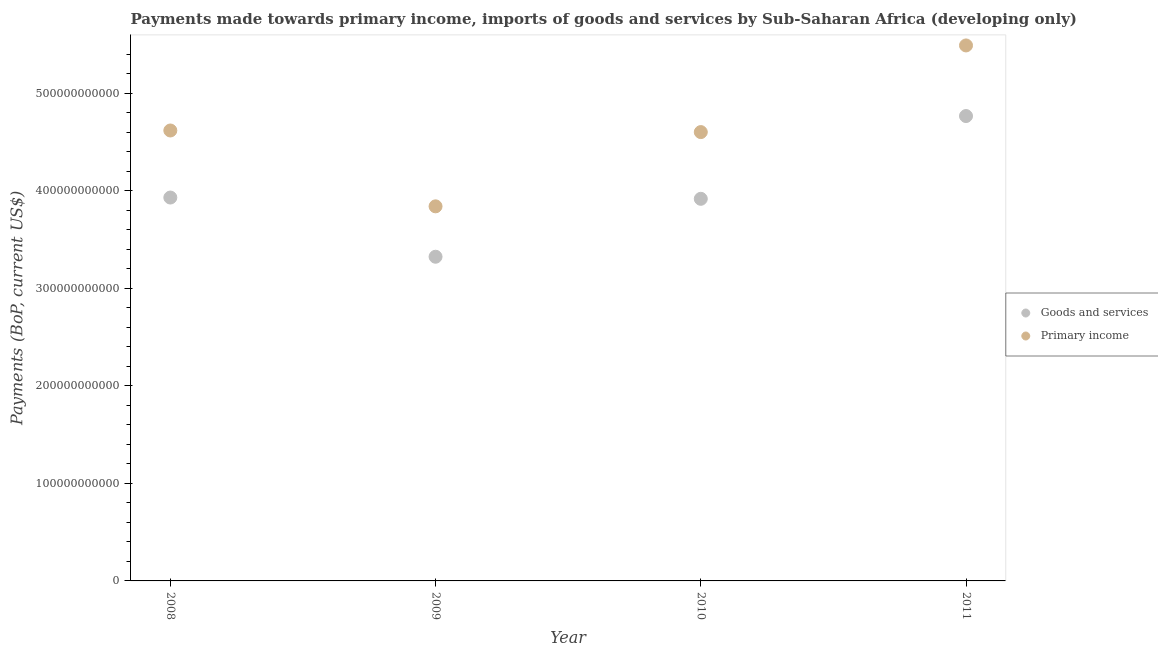Is the number of dotlines equal to the number of legend labels?
Ensure brevity in your answer.  Yes. What is the payments made towards goods and services in 2011?
Make the answer very short. 4.76e+11. Across all years, what is the maximum payments made towards goods and services?
Offer a terse response. 4.76e+11. Across all years, what is the minimum payments made towards goods and services?
Ensure brevity in your answer.  3.32e+11. In which year was the payments made towards primary income minimum?
Provide a short and direct response. 2009. What is the total payments made towards goods and services in the graph?
Offer a terse response. 1.59e+12. What is the difference between the payments made towards goods and services in 2008 and that in 2009?
Your response must be concise. 6.07e+1. What is the difference between the payments made towards goods and services in 2011 and the payments made towards primary income in 2010?
Your answer should be compact. 1.64e+1. What is the average payments made towards goods and services per year?
Keep it short and to the point. 3.98e+11. In the year 2011, what is the difference between the payments made towards goods and services and payments made towards primary income?
Your response must be concise. -7.24e+1. What is the ratio of the payments made towards goods and services in 2009 to that in 2011?
Your answer should be very brief. 0.7. Is the payments made towards primary income in 2009 less than that in 2010?
Offer a very short reply. Yes. What is the difference between the highest and the second highest payments made towards goods and services?
Keep it short and to the point. 8.35e+1. What is the difference between the highest and the lowest payments made towards goods and services?
Your answer should be compact. 1.44e+11. In how many years, is the payments made towards primary income greater than the average payments made towards primary income taken over all years?
Offer a terse response. 1. Is the sum of the payments made towards goods and services in 2009 and 2010 greater than the maximum payments made towards primary income across all years?
Offer a very short reply. Yes. How many dotlines are there?
Your answer should be compact. 2. What is the difference between two consecutive major ticks on the Y-axis?
Provide a succinct answer. 1.00e+11. Are the values on the major ticks of Y-axis written in scientific E-notation?
Your response must be concise. No. Does the graph contain any zero values?
Provide a short and direct response. No. Does the graph contain grids?
Keep it short and to the point. No. Where does the legend appear in the graph?
Your response must be concise. Center right. What is the title of the graph?
Your response must be concise. Payments made towards primary income, imports of goods and services by Sub-Saharan Africa (developing only). Does "GDP at market prices" appear as one of the legend labels in the graph?
Your answer should be very brief. No. What is the label or title of the X-axis?
Give a very brief answer. Year. What is the label or title of the Y-axis?
Keep it short and to the point. Payments (BoP, current US$). What is the Payments (BoP, current US$) in Goods and services in 2008?
Offer a terse response. 3.93e+11. What is the Payments (BoP, current US$) of Primary income in 2008?
Give a very brief answer. 4.62e+11. What is the Payments (BoP, current US$) in Goods and services in 2009?
Offer a very short reply. 3.32e+11. What is the Payments (BoP, current US$) of Primary income in 2009?
Ensure brevity in your answer.  3.84e+11. What is the Payments (BoP, current US$) of Goods and services in 2010?
Make the answer very short. 3.92e+11. What is the Payments (BoP, current US$) of Primary income in 2010?
Your answer should be very brief. 4.60e+11. What is the Payments (BoP, current US$) of Goods and services in 2011?
Make the answer very short. 4.76e+11. What is the Payments (BoP, current US$) of Primary income in 2011?
Your response must be concise. 5.49e+11. Across all years, what is the maximum Payments (BoP, current US$) of Goods and services?
Offer a terse response. 4.76e+11. Across all years, what is the maximum Payments (BoP, current US$) of Primary income?
Offer a terse response. 5.49e+11. Across all years, what is the minimum Payments (BoP, current US$) in Goods and services?
Give a very brief answer. 3.32e+11. Across all years, what is the minimum Payments (BoP, current US$) of Primary income?
Ensure brevity in your answer.  3.84e+11. What is the total Payments (BoP, current US$) of Goods and services in the graph?
Provide a short and direct response. 1.59e+12. What is the total Payments (BoP, current US$) in Primary income in the graph?
Give a very brief answer. 1.85e+12. What is the difference between the Payments (BoP, current US$) in Goods and services in 2008 and that in 2009?
Give a very brief answer. 6.07e+1. What is the difference between the Payments (BoP, current US$) of Primary income in 2008 and that in 2009?
Your response must be concise. 7.77e+1. What is the difference between the Payments (BoP, current US$) in Goods and services in 2008 and that in 2010?
Provide a short and direct response. 1.30e+09. What is the difference between the Payments (BoP, current US$) in Primary income in 2008 and that in 2010?
Keep it short and to the point. 1.64e+09. What is the difference between the Payments (BoP, current US$) in Goods and services in 2008 and that in 2011?
Offer a terse response. -8.35e+1. What is the difference between the Payments (BoP, current US$) of Primary income in 2008 and that in 2011?
Provide a short and direct response. -8.72e+1. What is the difference between the Payments (BoP, current US$) of Goods and services in 2009 and that in 2010?
Give a very brief answer. -5.94e+1. What is the difference between the Payments (BoP, current US$) in Primary income in 2009 and that in 2010?
Provide a short and direct response. -7.61e+1. What is the difference between the Payments (BoP, current US$) in Goods and services in 2009 and that in 2011?
Your answer should be compact. -1.44e+11. What is the difference between the Payments (BoP, current US$) of Primary income in 2009 and that in 2011?
Offer a terse response. -1.65e+11. What is the difference between the Payments (BoP, current US$) in Goods and services in 2010 and that in 2011?
Your response must be concise. -8.48e+1. What is the difference between the Payments (BoP, current US$) of Primary income in 2010 and that in 2011?
Give a very brief answer. -8.88e+1. What is the difference between the Payments (BoP, current US$) in Goods and services in 2008 and the Payments (BoP, current US$) in Primary income in 2009?
Give a very brief answer. 9.02e+09. What is the difference between the Payments (BoP, current US$) in Goods and services in 2008 and the Payments (BoP, current US$) in Primary income in 2010?
Your answer should be very brief. -6.71e+1. What is the difference between the Payments (BoP, current US$) in Goods and services in 2008 and the Payments (BoP, current US$) in Primary income in 2011?
Make the answer very short. -1.56e+11. What is the difference between the Payments (BoP, current US$) in Goods and services in 2009 and the Payments (BoP, current US$) in Primary income in 2010?
Your answer should be compact. -1.28e+11. What is the difference between the Payments (BoP, current US$) of Goods and services in 2009 and the Payments (BoP, current US$) of Primary income in 2011?
Keep it short and to the point. -2.17e+11. What is the difference between the Payments (BoP, current US$) of Goods and services in 2010 and the Payments (BoP, current US$) of Primary income in 2011?
Your response must be concise. -1.57e+11. What is the average Payments (BoP, current US$) of Goods and services per year?
Keep it short and to the point. 3.98e+11. What is the average Payments (BoP, current US$) in Primary income per year?
Your answer should be compact. 4.64e+11. In the year 2008, what is the difference between the Payments (BoP, current US$) of Goods and services and Payments (BoP, current US$) of Primary income?
Your answer should be very brief. -6.87e+1. In the year 2009, what is the difference between the Payments (BoP, current US$) in Goods and services and Payments (BoP, current US$) in Primary income?
Make the answer very short. -5.17e+1. In the year 2010, what is the difference between the Payments (BoP, current US$) of Goods and services and Payments (BoP, current US$) of Primary income?
Offer a terse response. -6.84e+1. In the year 2011, what is the difference between the Payments (BoP, current US$) of Goods and services and Payments (BoP, current US$) of Primary income?
Give a very brief answer. -7.24e+1. What is the ratio of the Payments (BoP, current US$) in Goods and services in 2008 to that in 2009?
Your response must be concise. 1.18. What is the ratio of the Payments (BoP, current US$) of Primary income in 2008 to that in 2009?
Give a very brief answer. 1.2. What is the ratio of the Payments (BoP, current US$) of Goods and services in 2008 to that in 2011?
Offer a terse response. 0.82. What is the ratio of the Payments (BoP, current US$) of Primary income in 2008 to that in 2011?
Offer a very short reply. 0.84. What is the ratio of the Payments (BoP, current US$) of Goods and services in 2009 to that in 2010?
Your answer should be very brief. 0.85. What is the ratio of the Payments (BoP, current US$) of Primary income in 2009 to that in 2010?
Make the answer very short. 0.83. What is the ratio of the Payments (BoP, current US$) in Goods and services in 2009 to that in 2011?
Ensure brevity in your answer.  0.7. What is the ratio of the Payments (BoP, current US$) in Primary income in 2009 to that in 2011?
Your answer should be compact. 0.7. What is the ratio of the Payments (BoP, current US$) in Goods and services in 2010 to that in 2011?
Your answer should be compact. 0.82. What is the ratio of the Payments (BoP, current US$) in Primary income in 2010 to that in 2011?
Make the answer very short. 0.84. What is the difference between the highest and the second highest Payments (BoP, current US$) in Goods and services?
Ensure brevity in your answer.  8.35e+1. What is the difference between the highest and the second highest Payments (BoP, current US$) of Primary income?
Keep it short and to the point. 8.72e+1. What is the difference between the highest and the lowest Payments (BoP, current US$) of Goods and services?
Offer a terse response. 1.44e+11. What is the difference between the highest and the lowest Payments (BoP, current US$) in Primary income?
Keep it short and to the point. 1.65e+11. 